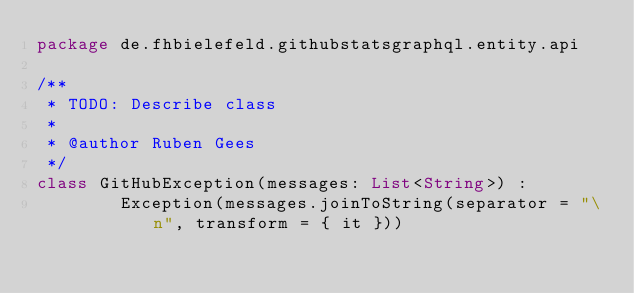Convert code to text. <code><loc_0><loc_0><loc_500><loc_500><_Kotlin_>package de.fhbielefeld.githubstatsgraphql.entity.api

/**
 * TODO: Describe class
 *
 * @author Ruben Gees
 */
class GitHubException(messages: List<String>) :
        Exception(messages.joinToString(separator = "\n", transform = { it }))</code> 